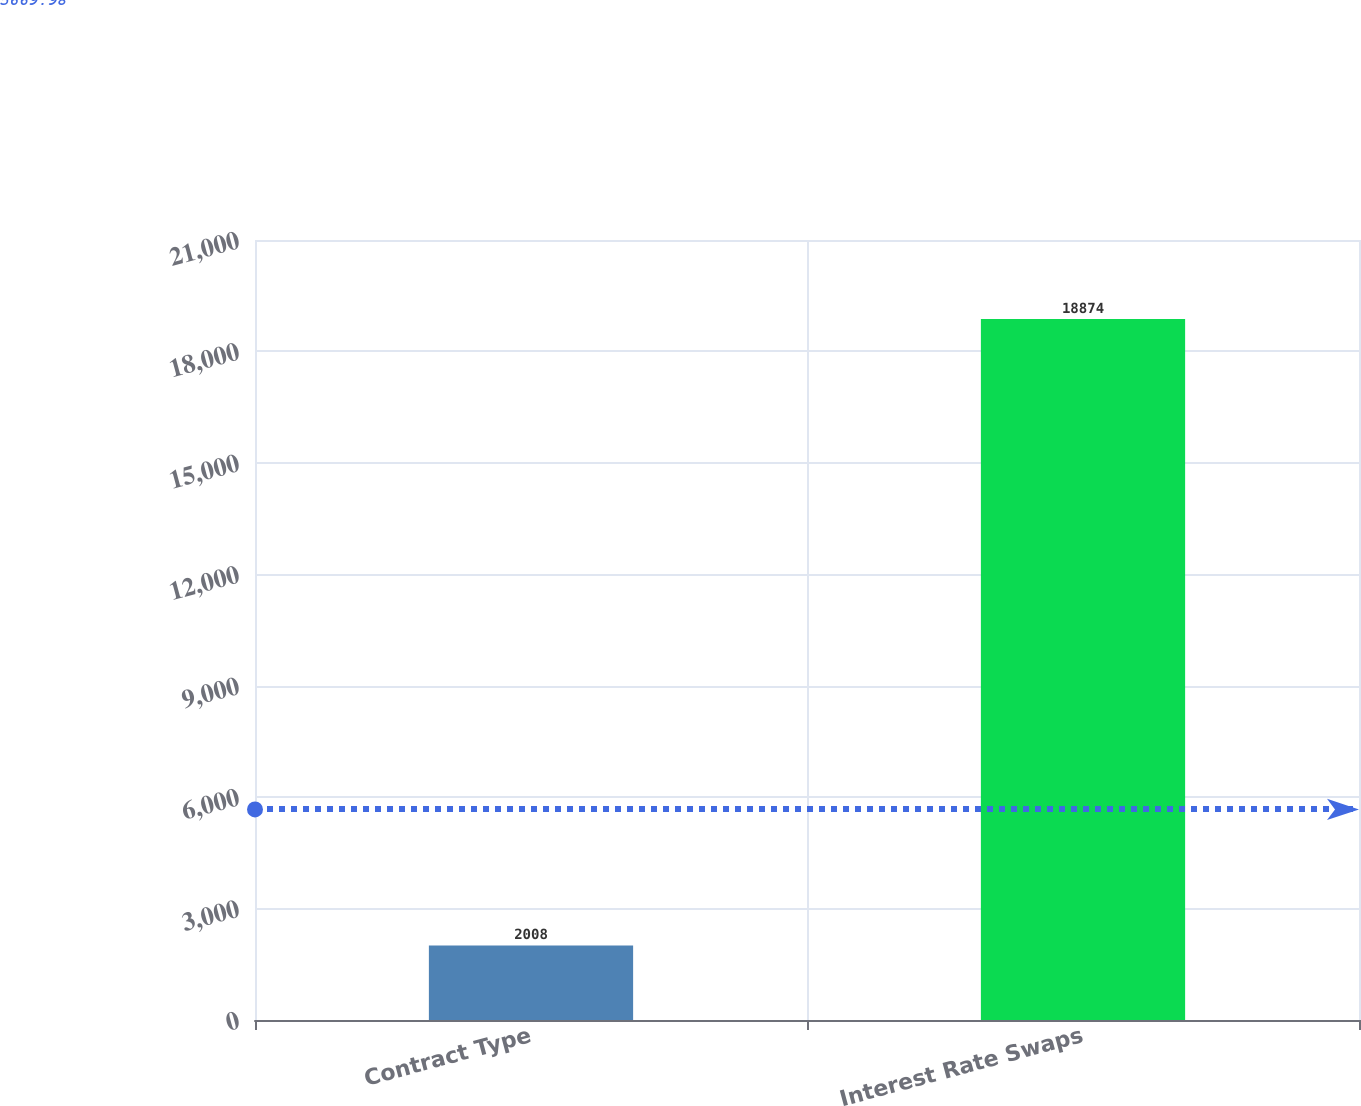Convert chart. <chart><loc_0><loc_0><loc_500><loc_500><bar_chart><fcel>Contract Type<fcel>Interest Rate Swaps<nl><fcel>2008<fcel>18874<nl></chart> 